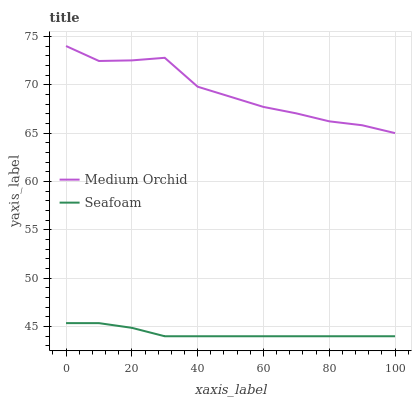Does Seafoam have the minimum area under the curve?
Answer yes or no. Yes. Does Medium Orchid have the maximum area under the curve?
Answer yes or no. Yes. Does Seafoam have the maximum area under the curve?
Answer yes or no. No. Is Seafoam the smoothest?
Answer yes or no. Yes. Is Medium Orchid the roughest?
Answer yes or no. Yes. Is Seafoam the roughest?
Answer yes or no. No. Does Seafoam have the lowest value?
Answer yes or no. Yes. Does Medium Orchid have the highest value?
Answer yes or no. Yes. Does Seafoam have the highest value?
Answer yes or no. No. Is Seafoam less than Medium Orchid?
Answer yes or no. Yes. Is Medium Orchid greater than Seafoam?
Answer yes or no. Yes. Does Seafoam intersect Medium Orchid?
Answer yes or no. No. 